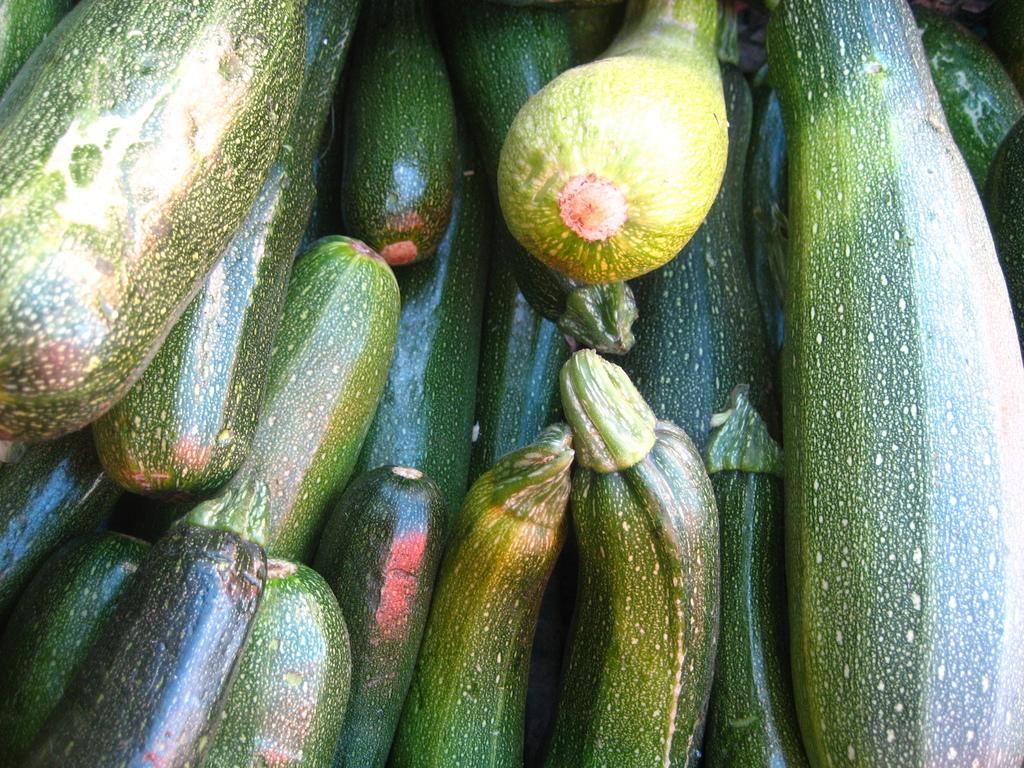What type of food items are present in the image? There are vegetables in the image. What type of dirt can be seen on the vegetables in the image? There is no dirt visible on the vegetables in the image. Is there a veil covering the vegetables in the image? There is no veil present in the image; it only features vegetables. 